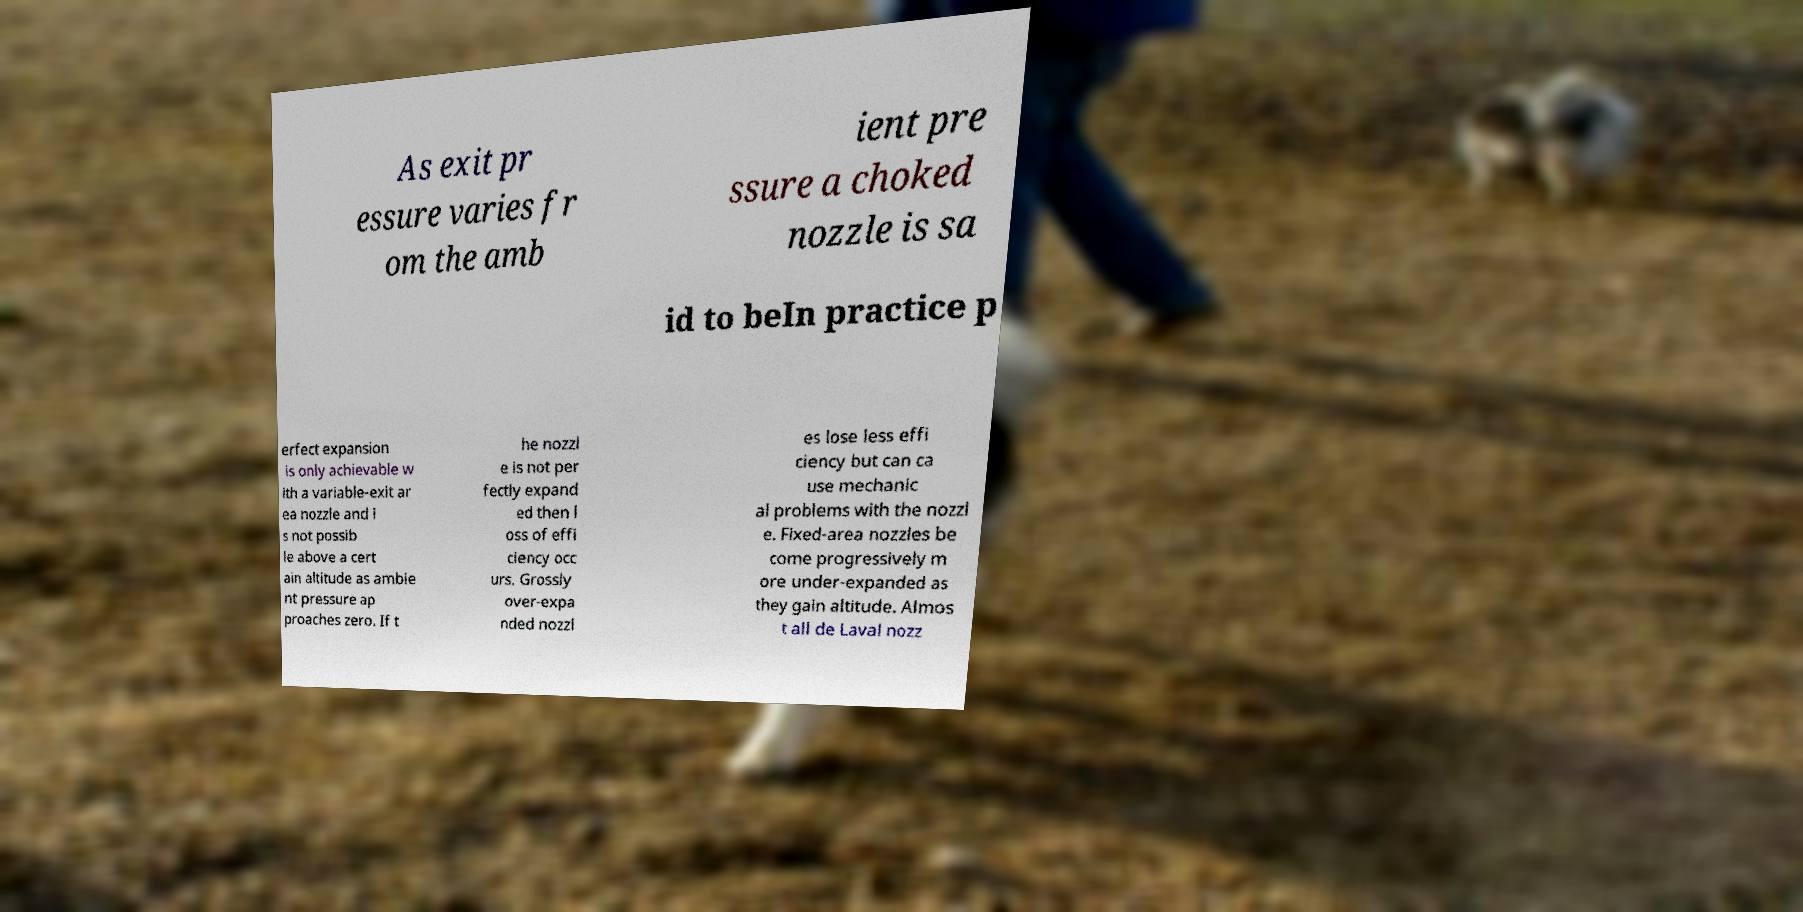For documentation purposes, I need the text within this image transcribed. Could you provide that? As exit pr essure varies fr om the amb ient pre ssure a choked nozzle is sa id to beIn practice p erfect expansion is only achievable w ith a variable-exit ar ea nozzle and i s not possib le above a cert ain altitude as ambie nt pressure ap proaches zero. If t he nozzl e is not per fectly expand ed then l oss of effi ciency occ urs. Grossly over-expa nded nozzl es lose less effi ciency but can ca use mechanic al problems with the nozzl e. Fixed-area nozzles be come progressively m ore under-expanded as they gain altitude. Almos t all de Laval nozz 